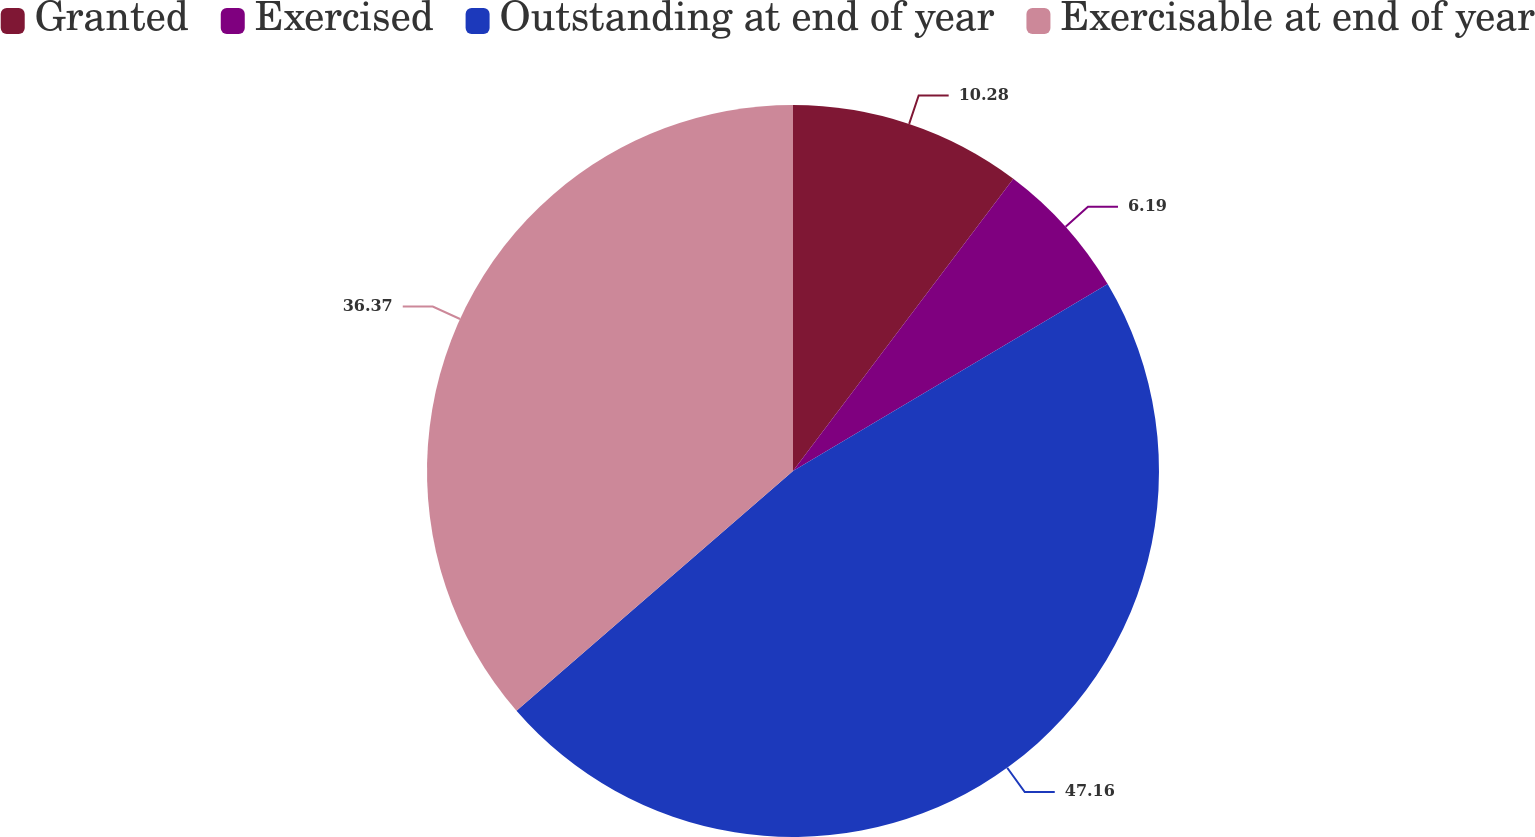Convert chart to OTSL. <chart><loc_0><loc_0><loc_500><loc_500><pie_chart><fcel>Granted<fcel>Exercised<fcel>Outstanding at end of year<fcel>Exercisable at end of year<nl><fcel>10.28%<fcel>6.19%<fcel>47.16%<fcel>36.37%<nl></chart> 